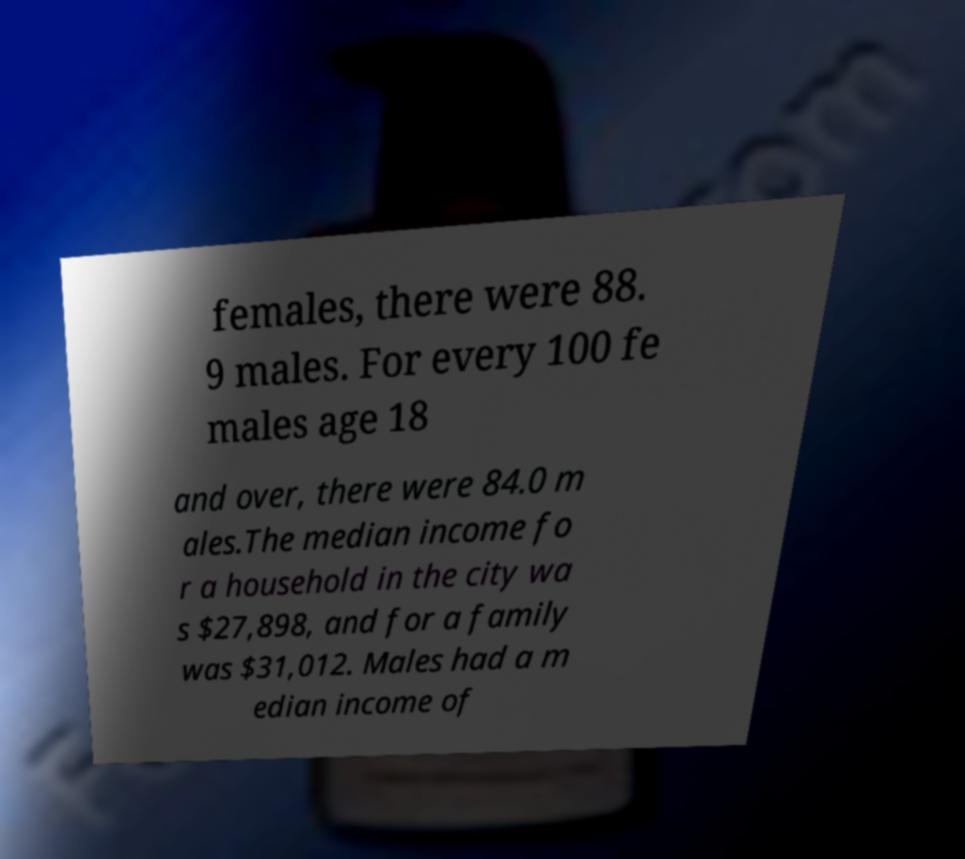Could you assist in decoding the text presented in this image and type it out clearly? females, there were 88. 9 males. For every 100 fe males age 18 and over, there were 84.0 m ales.The median income fo r a household in the city wa s $27,898, and for a family was $31,012. Males had a m edian income of 